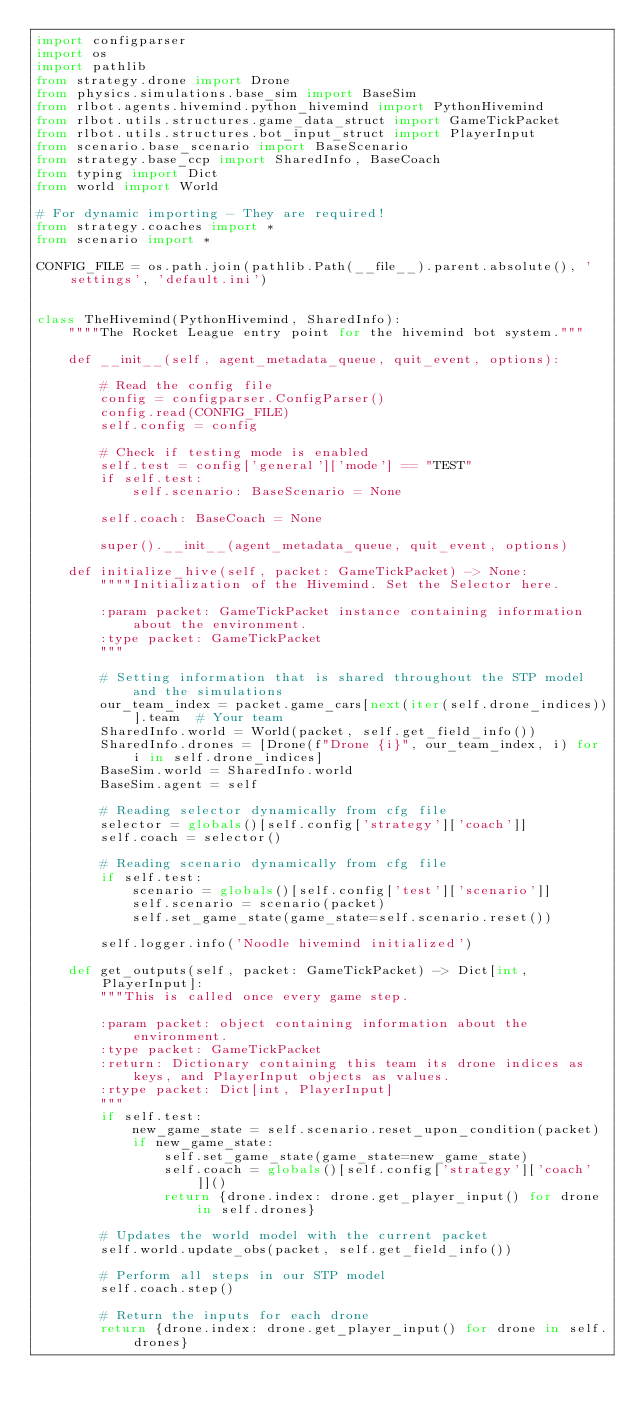<code> <loc_0><loc_0><loc_500><loc_500><_Python_>import configparser
import os
import pathlib
from strategy.drone import Drone
from physics.simulations.base_sim import BaseSim
from rlbot.agents.hivemind.python_hivemind import PythonHivemind
from rlbot.utils.structures.game_data_struct import GameTickPacket
from rlbot.utils.structures.bot_input_struct import PlayerInput
from scenario.base_scenario import BaseScenario
from strategy.base_ccp import SharedInfo, BaseCoach
from typing import Dict
from world import World

# For dynamic importing - They are required!
from strategy.coaches import *
from scenario import *

CONFIG_FILE = os.path.join(pathlib.Path(__file__).parent.absolute(), 'settings', 'default.ini')


class TheHivemind(PythonHivemind, SharedInfo):
    """"The Rocket League entry point for the hivemind bot system."""

    def __init__(self, agent_metadata_queue, quit_event, options):

        # Read the config file
        config = configparser.ConfigParser()
        config.read(CONFIG_FILE)
        self.config = config

        # Check if testing mode is enabled
        self.test = config['general']['mode'] == "TEST"
        if self.test:
            self.scenario: BaseScenario = None

        self.coach: BaseCoach = None

        super().__init__(agent_metadata_queue, quit_event, options)

    def initialize_hive(self, packet: GameTickPacket) -> None:
        """"Initialization of the Hivemind. Set the Selector here.

        :param packet: GameTickPacket instance containing information about the environment.
        :type packet: GameTickPacket
        """

        # Setting information that is shared throughout the STP model and the simulations
        our_team_index = packet.game_cars[next(iter(self.drone_indices))].team  # Your team
        SharedInfo.world = World(packet, self.get_field_info())
        SharedInfo.drones = [Drone(f"Drone {i}", our_team_index, i) for i in self.drone_indices]
        BaseSim.world = SharedInfo.world
        BaseSim.agent = self

        # Reading selector dynamically from cfg file
        selector = globals()[self.config['strategy']['coach']]
        self.coach = selector()

        # Reading scenario dynamically from cfg file
        if self.test:
            scenario = globals()[self.config['test']['scenario']]
            self.scenario = scenario(packet)
            self.set_game_state(game_state=self.scenario.reset())

        self.logger.info('Noodle hivemind initialized')

    def get_outputs(self, packet: GameTickPacket) -> Dict[int, PlayerInput]:
        """This is called once every game step.

        :param packet: object containing information about the environment.
        :type packet: GameTickPacket
        :return: Dictionary containing this team its drone indices as keys, and PlayerInput objects as values.
        :rtype packet: Dict[int, PlayerInput]
        """
        if self.test:
            new_game_state = self.scenario.reset_upon_condition(packet)
            if new_game_state:
                self.set_game_state(game_state=new_game_state)
                self.coach = globals()[self.config['strategy']['coach']]()
                return {drone.index: drone.get_player_input() for drone in self.drones}

        # Updates the world model with the current packet
        self.world.update_obs(packet, self.get_field_info())

        # Perform all steps in our STP model
        self.coach.step()

        # Return the inputs for each drone
        return {drone.index: drone.get_player_input() for drone in self.drones}
</code> 